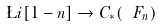<formula> <loc_0><loc_0><loc_500><loc_500>\L i [ 1 - n ] \to C _ { * } ( \ F _ { n } )</formula> 